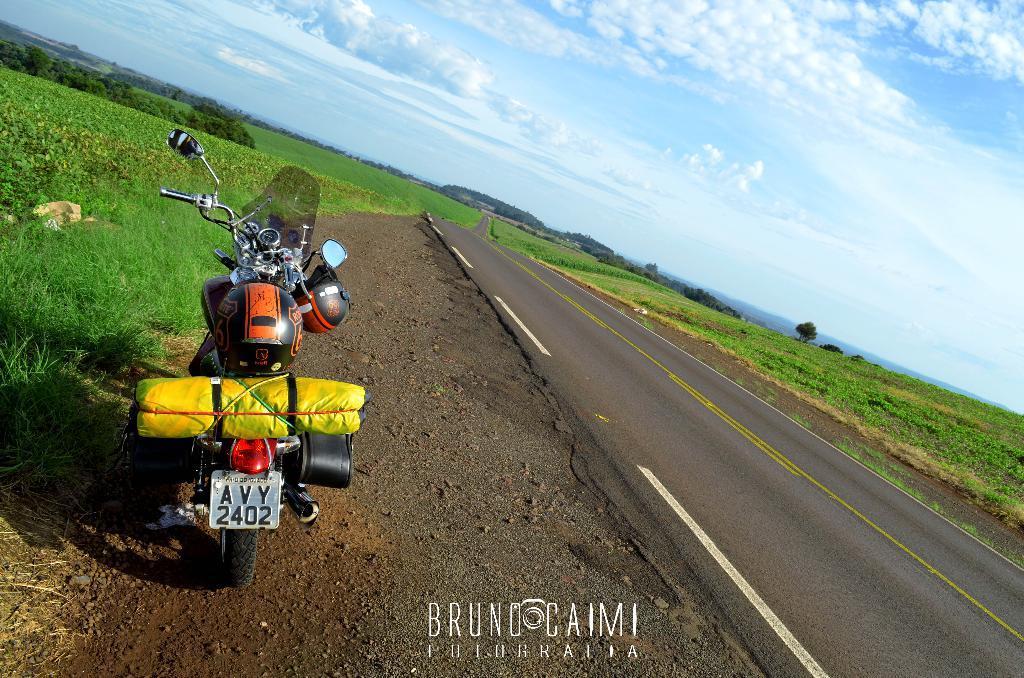In one or two sentences, can you explain what this image depicts? In this image there is a bike on the land. On the bike there are helmets and a bag. Right side there is a road. Background there are plants and trees on the grassland. Top of the image there is sky, having clouds. Right side there are hills. 